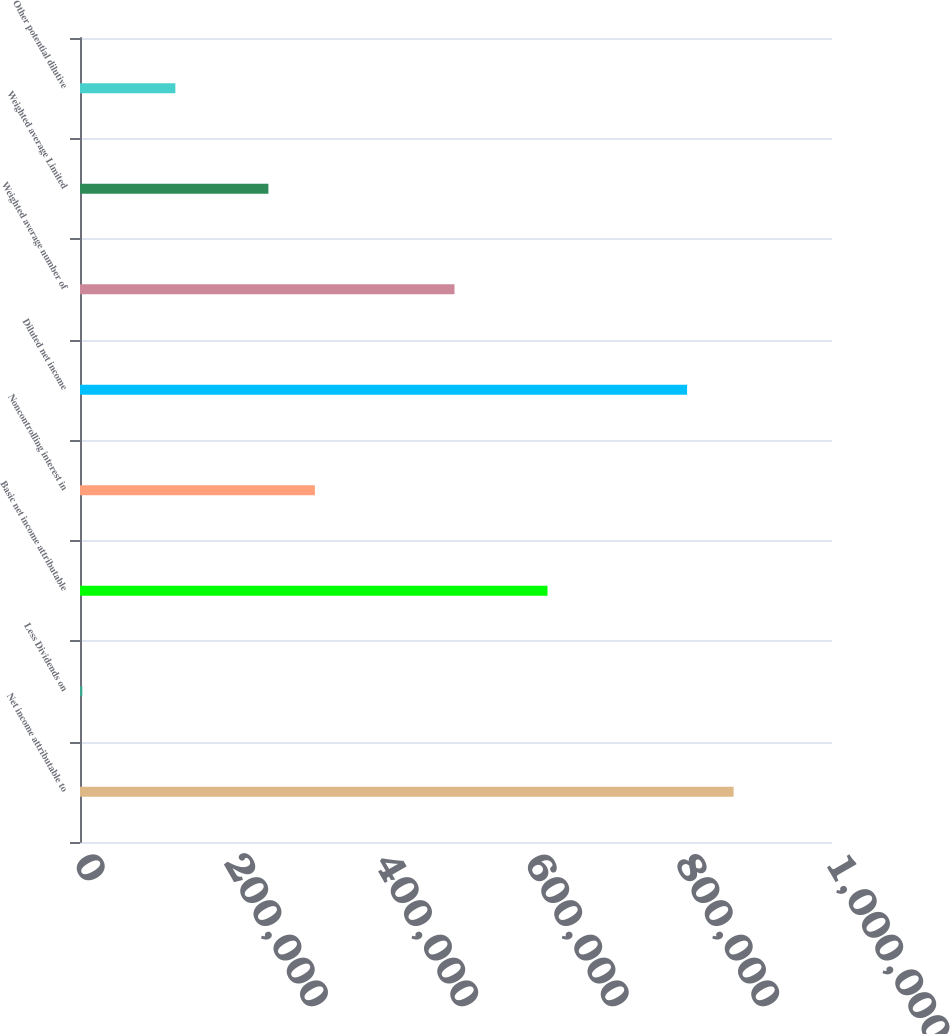<chart> <loc_0><loc_0><loc_500><loc_500><bar_chart><fcel>Net income attributable to<fcel>Less Dividends on<fcel>Basic net income attributable<fcel>Noncontrolling interest in<fcel>Diluted net income<fcel>Weighted average number of<fcel>Weighted average Limited<fcel>Other potential dilutive<nl><fcel>869167<fcel>3081<fcel>621714<fcel>312398<fcel>807304<fcel>497987<fcel>250534<fcel>126808<nl></chart> 